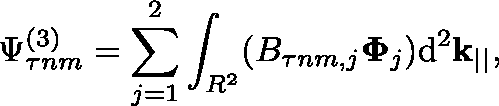Convert formula to latex. <formula><loc_0><loc_0><loc_500><loc_500>\Psi _ { \tau n m } ^ { ( 3 ) } = \sum _ { j = 1 } ^ { 2 } \int _ { \mathbb { R } ^ { 2 } } ( B _ { \tau n m , j } \Phi _ { j } ) d ^ { 2 } k _ { | | } ,</formula> 